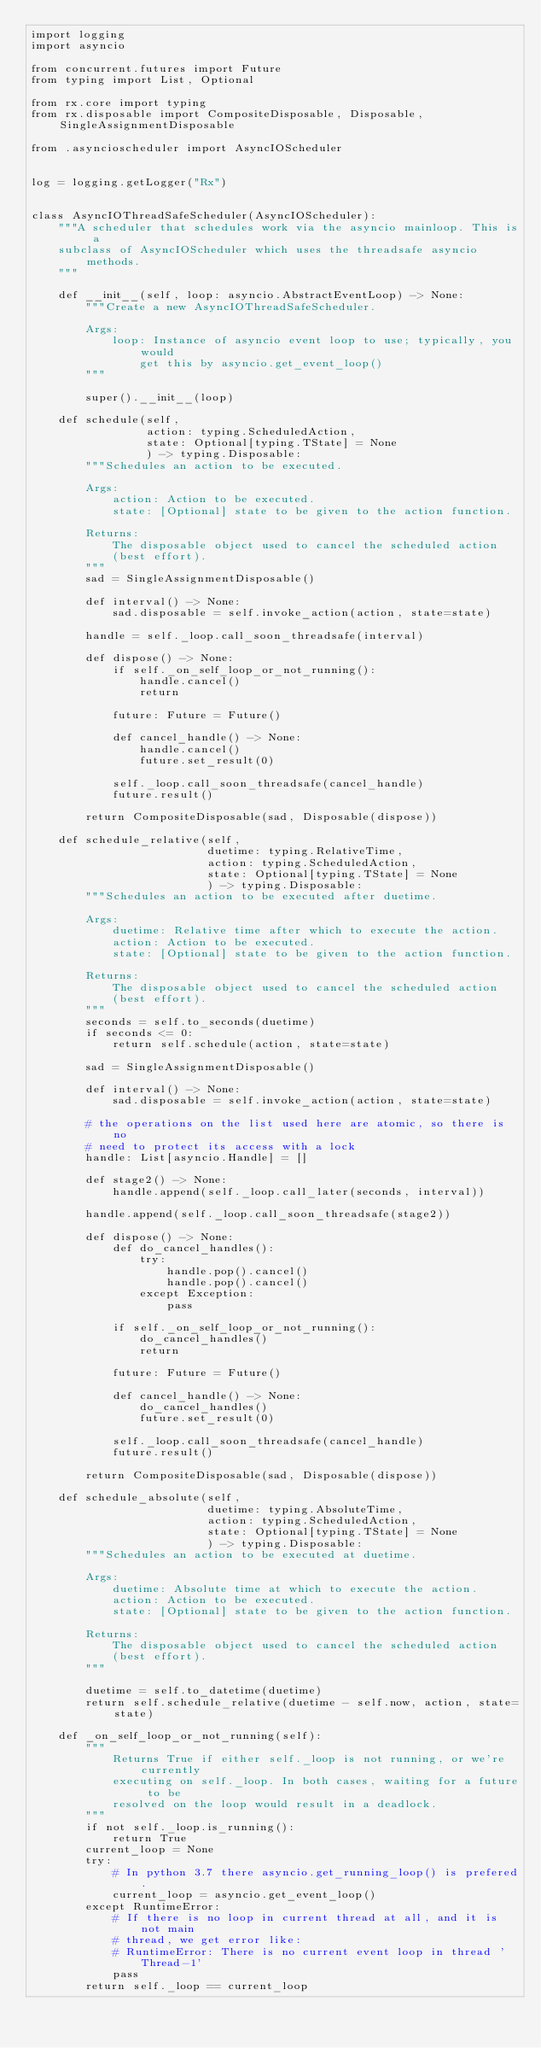<code> <loc_0><loc_0><loc_500><loc_500><_Python_>import logging
import asyncio

from concurrent.futures import Future
from typing import List, Optional

from rx.core import typing
from rx.disposable import CompositeDisposable, Disposable, SingleAssignmentDisposable

from .asyncioscheduler import AsyncIOScheduler


log = logging.getLogger("Rx")


class AsyncIOThreadSafeScheduler(AsyncIOScheduler):
    """A scheduler that schedules work via the asyncio mainloop. This is a
    subclass of AsyncIOScheduler which uses the threadsafe asyncio methods.
    """

    def __init__(self, loop: asyncio.AbstractEventLoop) -> None:
        """Create a new AsyncIOThreadSafeScheduler.

        Args:
            loop: Instance of asyncio event loop to use; typically, you would
                get this by asyncio.get_event_loop()
        """

        super().__init__(loop)

    def schedule(self,
                 action: typing.ScheduledAction,
                 state: Optional[typing.TState] = None
                 ) -> typing.Disposable:
        """Schedules an action to be executed.

        Args:
            action: Action to be executed.
            state: [Optional] state to be given to the action function.

        Returns:
            The disposable object used to cancel the scheduled action
            (best effort).
        """
        sad = SingleAssignmentDisposable()

        def interval() -> None:
            sad.disposable = self.invoke_action(action, state=state)

        handle = self._loop.call_soon_threadsafe(interval)

        def dispose() -> None:
            if self._on_self_loop_or_not_running():
                handle.cancel()
                return

            future: Future = Future()

            def cancel_handle() -> None:
                handle.cancel()
                future.set_result(0)

            self._loop.call_soon_threadsafe(cancel_handle)
            future.result()

        return CompositeDisposable(sad, Disposable(dispose))

    def schedule_relative(self,
                          duetime: typing.RelativeTime,
                          action: typing.ScheduledAction,
                          state: Optional[typing.TState] = None
                          ) -> typing.Disposable:
        """Schedules an action to be executed after duetime.

        Args:
            duetime: Relative time after which to execute the action.
            action: Action to be executed.
            state: [Optional] state to be given to the action function.

        Returns:
            The disposable object used to cancel the scheduled action
            (best effort).
        """
        seconds = self.to_seconds(duetime)
        if seconds <= 0:
            return self.schedule(action, state=state)

        sad = SingleAssignmentDisposable()

        def interval() -> None:
            sad.disposable = self.invoke_action(action, state=state)

        # the operations on the list used here are atomic, so there is no
        # need to protect its access with a lock
        handle: List[asyncio.Handle] = []

        def stage2() -> None:
            handle.append(self._loop.call_later(seconds, interval))

        handle.append(self._loop.call_soon_threadsafe(stage2))

        def dispose() -> None:
            def do_cancel_handles():
                try:
                    handle.pop().cancel()
                    handle.pop().cancel()
                except Exception:
                    pass

            if self._on_self_loop_or_not_running():
                do_cancel_handles()
                return

            future: Future = Future()

            def cancel_handle() -> None:
                do_cancel_handles()
                future.set_result(0)

            self._loop.call_soon_threadsafe(cancel_handle)
            future.result()

        return CompositeDisposable(sad, Disposable(dispose))

    def schedule_absolute(self,
                          duetime: typing.AbsoluteTime,
                          action: typing.ScheduledAction,
                          state: Optional[typing.TState] = None
                          ) -> typing.Disposable:
        """Schedules an action to be executed at duetime.

        Args:
            duetime: Absolute time at which to execute the action.
            action: Action to be executed.
            state: [Optional] state to be given to the action function.

        Returns:
            The disposable object used to cancel the scheduled action
            (best effort).
        """

        duetime = self.to_datetime(duetime)
        return self.schedule_relative(duetime - self.now, action, state=state)

    def _on_self_loop_or_not_running(self):
        """
            Returns True if either self._loop is not running, or we're currently
            executing on self._loop. In both cases, waiting for a future to be
            resolved on the loop would result in a deadlock.
        """
        if not self._loop.is_running():
            return True
        current_loop = None
        try:
            # In python 3.7 there asyncio.get_running_loop() is prefered.
            current_loop = asyncio.get_event_loop()
        except RuntimeError:
            # If there is no loop in current thread at all, and it is not main
            # thread, we get error like:
            # RuntimeError: There is no current event loop in thread 'Thread-1'
            pass
        return self._loop == current_loop
</code> 